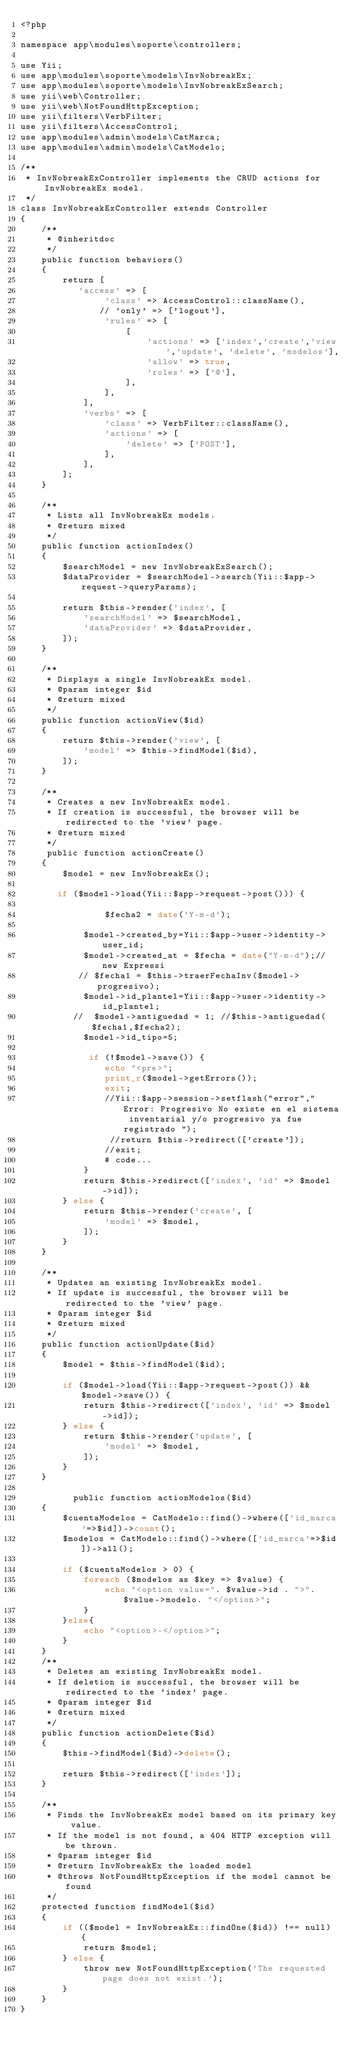<code> <loc_0><loc_0><loc_500><loc_500><_PHP_><?php

namespace app\modules\soporte\controllers;

use Yii;
use app\modules\soporte\models\InvNobreakEx;
use app\modules\soporte\models\InvNobreakExSearch;
use yii\web\Controller;
use yii\web\NotFoundHttpException;
use yii\filters\VerbFilter;
use yii\filters\AccessControl;
use app\modules\admin\models\CatMarca;
use app\modules\admin\models\CatModelo;

/**
 * InvNobreakExController implements the CRUD actions for InvNobreakEx model.
 */
class InvNobreakExController extends Controller
{
    /**
     * @inheritdoc
     */
    public function behaviors()
    {
        return [
           'access' => [
                'class' => AccessControl::className(),
               // 'only' => ['logout'],
                'rules' => [
                    [
                        'actions' => ['index','create','view','update', 'delete', 'modelos'],
                        'allow' => true,
                        'roles' => ['@'],
                    ],
                ],
            ],
            'verbs' => [
                'class' => VerbFilter::className(),
                'actions' => [
                    'delete' => ['POST'],
                ],
            ],
        ];
    }

    /**
     * Lists all InvNobreakEx models.
     * @return mixed
     */
    public function actionIndex()
    {
        $searchModel = new InvNobreakExSearch();
        $dataProvider = $searchModel->search(Yii::$app->request->queryParams);

        return $this->render('index', [
            'searchModel' => $searchModel,
            'dataProvider' => $dataProvider,
        ]);
    }

    /**
     * Displays a single InvNobreakEx model.
     * @param integer $id
     * @return mixed
     */
    public function actionView($id)
    {
        return $this->render('view', [
            'model' => $this->findModel($id),
        ]);
    }

    /**
     * Creates a new InvNobreakEx model.
     * If creation is successful, the browser will be redirected to the 'view' page.
     * @return mixed
     */
     public function actionCreate()
    {
        $model = new InvNobreakEx();

       if ($model->load(Yii::$app->request->post())) {

                $fecha2 = date('Y-m-d');

            $model->created_by=Yii::$app->user->identity->user_id;
            $model->created_at = $fecha = date("Y-m-d");//new Expressi
           // $fecha1 = $this->traerFechaInv($model->progresivo);
            $model->id_plantel=Yii::$app->user->identity->id_plantel;
          //  $model->antiguedad = 1; //$this->antiguedad($fecha1,$fecha2);
            $model->id_tipo=5;

             if (!$model->save()) {
                echo "<pre>";
                print_r($model->getErrors());
                exit;
                //Yii::$app->session->setflash("error","Error: Progresivo No existe en el sistema inventarial y/o progresivo ya fue registrado ");
                 //return $this->redirect(['create']);
                //exit;
                # code...
            }
            return $this->redirect(['index', 'id' => $model->id]);
        } else {
            return $this->render('create', [
                'model' => $model,
            ]);
        }
    }

    /**
     * Updates an existing InvNobreakEx model.
     * If update is successful, the browser will be redirected to the 'view' page.
     * @param integer $id
     * @return mixed
     */
    public function actionUpdate($id)
    {
        $model = $this->findModel($id);

        if ($model->load(Yii::$app->request->post()) && $model->save()) {
            return $this->redirect(['index', 'id' => $model->id]);
        } else {
            return $this->render('update', [
                'model' => $model,
            ]);
        }
    }

          public function actionModelos($id)
    {
        $cuentaModelos = CatModelo::find()->where(['id_marca'=>$id])->count();
        $modelos = CatModelo::find()->where(['id_marca'=>$id])->all();

        if ($cuentaModelos > 0) {
            foreach ($modelos as $key => $value) {
                echo "<option value=". $value->id . ">". $value->modelo. "</option>";
            }
        }else{
            echo "<option>-</option>";
        }
    }
    /**
     * Deletes an existing InvNobreakEx model.
     * If deletion is successful, the browser will be redirected to the 'index' page.
     * @param integer $id
     * @return mixed
     */
    public function actionDelete($id)
    {
        $this->findModel($id)->delete();

        return $this->redirect(['index']);
    }

    /**
     * Finds the InvNobreakEx model based on its primary key value.
     * If the model is not found, a 404 HTTP exception will be thrown.
     * @param integer $id
     * @return InvNobreakEx the loaded model
     * @throws NotFoundHttpException if the model cannot be found
     */
    protected function findModel($id)
    {
        if (($model = InvNobreakEx::findOne($id)) !== null) {
            return $model;
        } else {
            throw new NotFoundHttpException('The requested page does not exist.');
        }
    }
}
</code> 